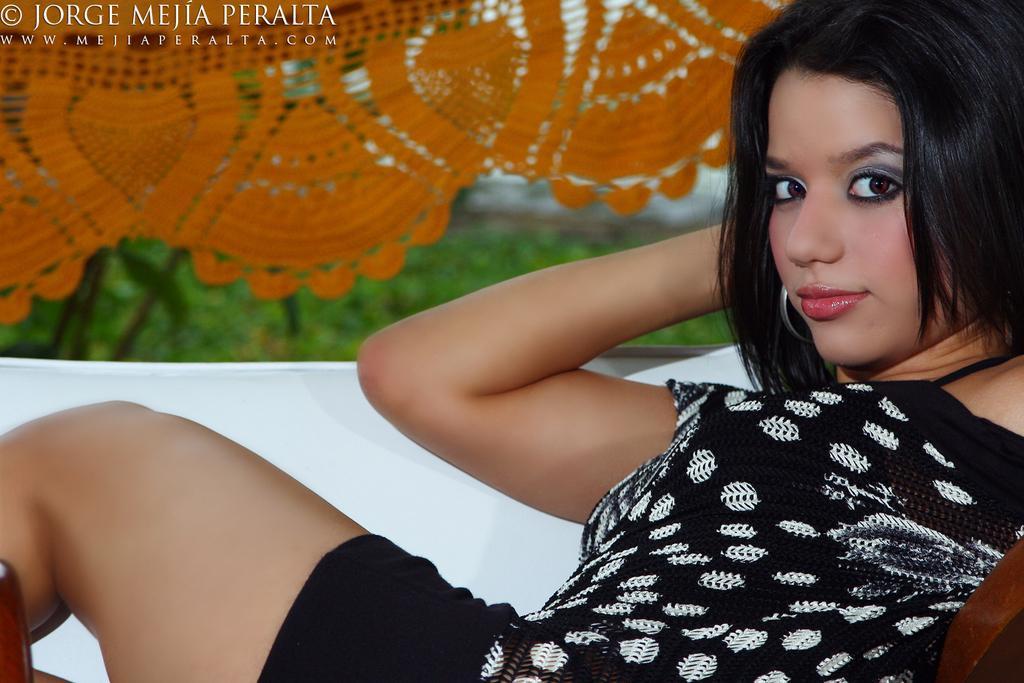In one or two sentences, can you explain what this image depicts? In the image there is a woman, she is posing for the photo and behind the woman there is orange color designer cloth and the background of the cloth is blur, there is some text at the top left corner of the image. 